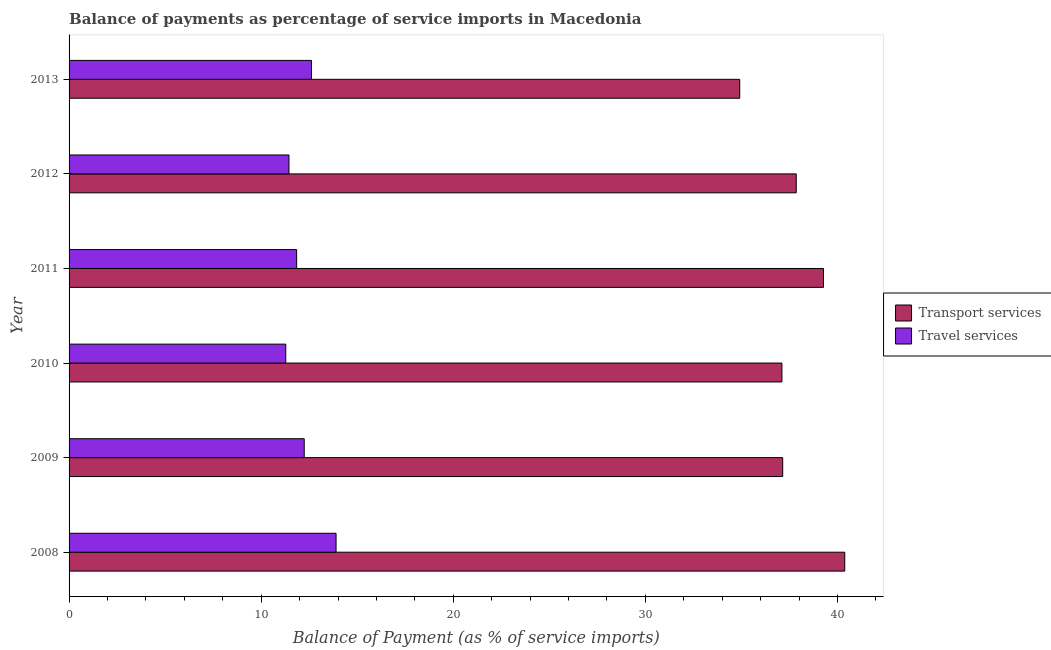Are the number of bars per tick equal to the number of legend labels?
Give a very brief answer. Yes. What is the label of the 6th group of bars from the top?
Your response must be concise. 2008. What is the balance of payments of travel services in 2008?
Your response must be concise. 13.9. Across all years, what is the maximum balance of payments of travel services?
Make the answer very short. 13.9. Across all years, what is the minimum balance of payments of travel services?
Make the answer very short. 11.28. In which year was the balance of payments of travel services maximum?
Ensure brevity in your answer.  2008. What is the total balance of payments of transport services in the graph?
Offer a terse response. 226.68. What is the difference between the balance of payments of transport services in 2010 and that in 2011?
Ensure brevity in your answer.  -2.16. What is the difference between the balance of payments of travel services in 2012 and the balance of payments of transport services in 2009?
Your answer should be very brief. -25.7. What is the average balance of payments of transport services per year?
Give a very brief answer. 37.78. In the year 2010, what is the difference between the balance of payments of travel services and balance of payments of transport services?
Provide a succinct answer. -25.83. What is the ratio of the balance of payments of travel services in 2010 to that in 2012?
Provide a succinct answer. 0.98. Is the balance of payments of transport services in 2010 less than that in 2012?
Offer a terse response. Yes. What is the difference between the highest and the second highest balance of payments of transport services?
Provide a short and direct response. 1.11. What is the difference between the highest and the lowest balance of payments of travel services?
Ensure brevity in your answer.  2.62. In how many years, is the balance of payments of transport services greater than the average balance of payments of transport services taken over all years?
Give a very brief answer. 3. Is the sum of the balance of payments of transport services in 2009 and 2011 greater than the maximum balance of payments of travel services across all years?
Your answer should be very brief. Yes. What does the 2nd bar from the top in 2013 represents?
Keep it short and to the point. Transport services. What does the 2nd bar from the bottom in 2009 represents?
Your answer should be very brief. Travel services. Are the values on the major ticks of X-axis written in scientific E-notation?
Ensure brevity in your answer.  No. What is the title of the graph?
Give a very brief answer. Balance of payments as percentage of service imports in Macedonia. Does "Investment" appear as one of the legend labels in the graph?
Your answer should be very brief. No. What is the label or title of the X-axis?
Your answer should be very brief. Balance of Payment (as % of service imports). What is the Balance of Payment (as % of service imports) in Transport services in 2008?
Keep it short and to the point. 40.38. What is the Balance of Payment (as % of service imports) in Travel services in 2008?
Provide a succinct answer. 13.9. What is the Balance of Payment (as % of service imports) in Transport services in 2009?
Provide a short and direct response. 37.15. What is the Balance of Payment (as % of service imports) of Travel services in 2009?
Offer a very short reply. 12.24. What is the Balance of Payment (as % of service imports) in Transport services in 2010?
Your answer should be very brief. 37.11. What is the Balance of Payment (as % of service imports) of Travel services in 2010?
Offer a very short reply. 11.28. What is the Balance of Payment (as % of service imports) in Transport services in 2011?
Offer a terse response. 39.27. What is the Balance of Payment (as % of service imports) of Travel services in 2011?
Keep it short and to the point. 11.85. What is the Balance of Payment (as % of service imports) of Transport services in 2012?
Make the answer very short. 37.86. What is the Balance of Payment (as % of service imports) of Travel services in 2012?
Your answer should be compact. 11.45. What is the Balance of Payment (as % of service imports) of Transport services in 2013?
Make the answer very short. 34.91. What is the Balance of Payment (as % of service imports) of Travel services in 2013?
Provide a succinct answer. 12.62. Across all years, what is the maximum Balance of Payment (as % of service imports) of Transport services?
Offer a very short reply. 40.38. Across all years, what is the maximum Balance of Payment (as % of service imports) in Travel services?
Provide a succinct answer. 13.9. Across all years, what is the minimum Balance of Payment (as % of service imports) of Transport services?
Make the answer very short. 34.91. Across all years, what is the minimum Balance of Payment (as % of service imports) in Travel services?
Keep it short and to the point. 11.28. What is the total Balance of Payment (as % of service imports) in Transport services in the graph?
Keep it short and to the point. 226.68. What is the total Balance of Payment (as % of service imports) in Travel services in the graph?
Keep it short and to the point. 73.33. What is the difference between the Balance of Payment (as % of service imports) in Transport services in 2008 and that in 2009?
Offer a very short reply. 3.23. What is the difference between the Balance of Payment (as % of service imports) of Travel services in 2008 and that in 2009?
Your answer should be compact. 1.66. What is the difference between the Balance of Payment (as % of service imports) of Transport services in 2008 and that in 2010?
Make the answer very short. 3.27. What is the difference between the Balance of Payment (as % of service imports) in Travel services in 2008 and that in 2010?
Ensure brevity in your answer.  2.62. What is the difference between the Balance of Payment (as % of service imports) of Transport services in 2008 and that in 2011?
Ensure brevity in your answer.  1.11. What is the difference between the Balance of Payment (as % of service imports) in Travel services in 2008 and that in 2011?
Offer a very short reply. 2.05. What is the difference between the Balance of Payment (as % of service imports) of Transport services in 2008 and that in 2012?
Your answer should be compact. 2.52. What is the difference between the Balance of Payment (as % of service imports) in Travel services in 2008 and that in 2012?
Make the answer very short. 2.45. What is the difference between the Balance of Payment (as % of service imports) in Transport services in 2008 and that in 2013?
Offer a very short reply. 5.47. What is the difference between the Balance of Payment (as % of service imports) in Travel services in 2008 and that in 2013?
Provide a short and direct response. 1.28. What is the difference between the Balance of Payment (as % of service imports) in Transport services in 2009 and that in 2010?
Your answer should be compact. 0.04. What is the difference between the Balance of Payment (as % of service imports) of Travel services in 2009 and that in 2010?
Offer a terse response. 0.96. What is the difference between the Balance of Payment (as % of service imports) in Transport services in 2009 and that in 2011?
Make the answer very short. -2.12. What is the difference between the Balance of Payment (as % of service imports) of Travel services in 2009 and that in 2011?
Give a very brief answer. 0.4. What is the difference between the Balance of Payment (as % of service imports) in Transport services in 2009 and that in 2012?
Give a very brief answer. -0.71. What is the difference between the Balance of Payment (as % of service imports) in Travel services in 2009 and that in 2012?
Offer a terse response. 0.79. What is the difference between the Balance of Payment (as % of service imports) in Transport services in 2009 and that in 2013?
Offer a terse response. 2.24. What is the difference between the Balance of Payment (as % of service imports) of Travel services in 2009 and that in 2013?
Make the answer very short. -0.38. What is the difference between the Balance of Payment (as % of service imports) of Transport services in 2010 and that in 2011?
Your response must be concise. -2.16. What is the difference between the Balance of Payment (as % of service imports) in Travel services in 2010 and that in 2011?
Offer a terse response. -0.57. What is the difference between the Balance of Payment (as % of service imports) of Transport services in 2010 and that in 2012?
Make the answer very short. -0.75. What is the difference between the Balance of Payment (as % of service imports) in Travel services in 2010 and that in 2012?
Provide a succinct answer. -0.17. What is the difference between the Balance of Payment (as % of service imports) in Transport services in 2010 and that in 2013?
Give a very brief answer. 2.2. What is the difference between the Balance of Payment (as % of service imports) in Travel services in 2010 and that in 2013?
Offer a terse response. -1.34. What is the difference between the Balance of Payment (as % of service imports) in Transport services in 2011 and that in 2012?
Provide a succinct answer. 1.42. What is the difference between the Balance of Payment (as % of service imports) of Travel services in 2011 and that in 2012?
Provide a succinct answer. 0.4. What is the difference between the Balance of Payment (as % of service imports) of Transport services in 2011 and that in 2013?
Your response must be concise. 4.36. What is the difference between the Balance of Payment (as % of service imports) in Travel services in 2011 and that in 2013?
Offer a terse response. -0.77. What is the difference between the Balance of Payment (as % of service imports) in Transport services in 2012 and that in 2013?
Offer a terse response. 2.94. What is the difference between the Balance of Payment (as % of service imports) in Travel services in 2012 and that in 2013?
Offer a very short reply. -1.17. What is the difference between the Balance of Payment (as % of service imports) in Transport services in 2008 and the Balance of Payment (as % of service imports) in Travel services in 2009?
Your answer should be compact. 28.14. What is the difference between the Balance of Payment (as % of service imports) of Transport services in 2008 and the Balance of Payment (as % of service imports) of Travel services in 2010?
Offer a very short reply. 29.1. What is the difference between the Balance of Payment (as % of service imports) of Transport services in 2008 and the Balance of Payment (as % of service imports) of Travel services in 2011?
Your answer should be very brief. 28.53. What is the difference between the Balance of Payment (as % of service imports) in Transport services in 2008 and the Balance of Payment (as % of service imports) in Travel services in 2012?
Keep it short and to the point. 28.93. What is the difference between the Balance of Payment (as % of service imports) in Transport services in 2008 and the Balance of Payment (as % of service imports) in Travel services in 2013?
Your answer should be very brief. 27.76. What is the difference between the Balance of Payment (as % of service imports) in Transport services in 2009 and the Balance of Payment (as % of service imports) in Travel services in 2010?
Give a very brief answer. 25.87. What is the difference between the Balance of Payment (as % of service imports) of Transport services in 2009 and the Balance of Payment (as % of service imports) of Travel services in 2011?
Provide a succinct answer. 25.3. What is the difference between the Balance of Payment (as % of service imports) in Transport services in 2009 and the Balance of Payment (as % of service imports) in Travel services in 2012?
Your response must be concise. 25.7. What is the difference between the Balance of Payment (as % of service imports) in Transport services in 2009 and the Balance of Payment (as % of service imports) in Travel services in 2013?
Give a very brief answer. 24.53. What is the difference between the Balance of Payment (as % of service imports) in Transport services in 2010 and the Balance of Payment (as % of service imports) in Travel services in 2011?
Your response must be concise. 25.26. What is the difference between the Balance of Payment (as % of service imports) of Transport services in 2010 and the Balance of Payment (as % of service imports) of Travel services in 2012?
Offer a very short reply. 25.66. What is the difference between the Balance of Payment (as % of service imports) in Transport services in 2010 and the Balance of Payment (as % of service imports) in Travel services in 2013?
Give a very brief answer. 24.49. What is the difference between the Balance of Payment (as % of service imports) of Transport services in 2011 and the Balance of Payment (as % of service imports) of Travel services in 2012?
Offer a very short reply. 27.83. What is the difference between the Balance of Payment (as % of service imports) of Transport services in 2011 and the Balance of Payment (as % of service imports) of Travel services in 2013?
Give a very brief answer. 26.65. What is the difference between the Balance of Payment (as % of service imports) in Transport services in 2012 and the Balance of Payment (as % of service imports) in Travel services in 2013?
Keep it short and to the point. 25.24. What is the average Balance of Payment (as % of service imports) in Transport services per year?
Your answer should be compact. 37.78. What is the average Balance of Payment (as % of service imports) in Travel services per year?
Make the answer very short. 12.22. In the year 2008, what is the difference between the Balance of Payment (as % of service imports) in Transport services and Balance of Payment (as % of service imports) in Travel services?
Your answer should be compact. 26.48. In the year 2009, what is the difference between the Balance of Payment (as % of service imports) in Transport services and Balance of Payment (as % of service imports) in Travel services?
Keep it short and to the point. 24.91. In the year 2010, what is the difference between the Balance of Payment (as % of service imports) in Transport services and Balance of Payment (as % of service imports) in Travel services?
Make the answer very short. 25.83. In the year 2011, what is the difference between the Balance of Payment (as % of service imports) of Transport services and Balance of Payment (as % of service imports) of Travel services?
Provide a succinct answer. 27.43. In the year 2012, what is the difference between the Balance of Payment (as % of service imports) in Transport services and Balance of Payment (as % of service imports) in Travel services?
Provide a short and direct response. 26.41. In the year 2013, what is the difference between the Balance of Payment (as % of service imports) in Transport services and Balance of Payment (as % of service imports) in Travel services?
Provide a succinct answer. 22.29. What is the ratio of the Balance of Payment (as % of service imports) of Transport services in 2008 to that in 2009?
Provide a short and direct response. 1.09. What is the ratio of the Balance of Payment (as % of service imports) in Travel services in 2008 to that in 2009?
Your answer should be very brief. 1.14. What is the ratio of the Balance of Payment (as % of service imports) of Transport services in 2008 to that in 2010?
Ensure brevity in your answer.  1.09. What is the ratio of the Balance of Payment (as % of service imports) in Travel services in 2008 to that in 2010?
Offer a very short reply. 1.23. What is the ratio of the Balance of Payment (as % of service imports) of Transport services in 2008 to that in 2011?
Your response must be concise. 1.03. What is the ratio of the Balance of Payment (as % of service imports) of Travel services in 2008 to that in 2011?
Provide a succinct answer. 1.17. What is the ratio of the Balance of Payment (as % of service imports) of Transport services in 2008 to that in 2012?
Make the answer very short. 1.07. What is the ratio of the Balance of Payment (as % of service imports) of Travel services in 2008 to that in 2012?
Make the answer very short. 1.21. What is the ratio of the Balance of Payment (as % of service imports) in Transport services in 2008 to that in 2013?
Ensure brevity in your answer.  1.16. What is the ratio of the Balance of Payment (as % of service imports) of Travel services in 2008 to that in 2013?
Provide a succinct answer. 1.1. What is the ratio of the Balance of Payment (as % of service imports) in Travel services in 2009 to that in 2010?
Your answer should be very brief. 1.09. What is the ratio of the Balance of Payment (as % of service imports) in Transport services in 2009 to that in 2011?
Provide a succinct answer. 0.95. What is the ratio of the Balance of Payment (as % of service imports) of Travel services in 2009 to that in 2011?
Your answer should be compact. 1.03. What is the ratio of the Balance of Payment (as % of service imports) of Transport services in 2009 to that in 2012?
Your response must be concise. 0.98. What is the ratio of the Balance of Payment (as % of service imports) of Travel services in 2009 to that in 2012?
Your answer should be compact. 1.07. What is the ratio of the Balance of Payment (as % of service imports) of Transport services in 2009 to that in 2013?
Make the answer very short. 1.06. What is the ratio of the Balance of Payment (as % of service imports) in Travel services in 2009 to that in 2013?
Offer a very short reply. 0.97. What is the ratio of the Balance of Payment (as % of service imports) in Transport services in 2010 to that in 2011?
Give a very brief answer. 0.94. What is the ratio of the Balance of Payment (as % of service imports) of Travel services in 2010 to that in 2011?
Offer a terse response. 0.95. What is the ratio of the Balance of Payment (as % of service imports) in Transport services in 2010 to that in 2012?
Keep it short and to the point. 0.98. What is the ratio of the Balance of Payment (as % of service imports) of Travel services in 2010 to that in 2012?
Keep it short and to the point. 0.99. What is the ratio of the Balance of Payment (as % of service imports) in Transport services in 2010 to that in 2013?
Your answer should be compact. 1.06. What is the ratio of the Balance of Payment (as % of service imports) in Travel services in 2010 to that in 2013?
Give a very brief answer. 0.89. What is the ratio of the Balance of Payment (as % of service imports) of Transport services in 2011 to that in 2012?
Ensure brevity in your answer.  1.04. What is the ratio of the Balance of Payment (as % of service imports) of Travel services in 2011 to that in 2012?
Provide a succinct answer. 1.03. What is the ratio of the Balance of Payment (as % of service imports) in Transport services in 2011 to that in 2013?
Offer a very short reply. 1.12. What is the ratio of the Balance of Payment (as % of service imports) of Travel services in 2011 to that in 2013?
Ensure brevity in your answer.  0.94. What is the ratio of the Balance of Payment (as % of service imports) of Transport services in 2012 to that in 2013?
Provide a short and direct response. 1.08. What is the ratio of the Balance of Payment (as % of service imports) of Travel services in 2012 to that in 2013?
Give a very brief answer. 0.91. What is the difference between the highest and the second highest Balance of Payment (as % of service imports) in Transport services?
Your answer should be very brief. 1.11. What is the difference between the highest and the second highest Balance of Payment (as % of service imports) of Travel services?
Your answer should be compact. 1.28. What is the difference between the highest and the lowest Balance of Payment (as % of service imports) of Transport services?
Keep it short and to the point. 5.47. What is the difference between the highest and the lowest Balance of Payment (as % of service imports) of Travel services?
Your response must be concise. 2.62. 